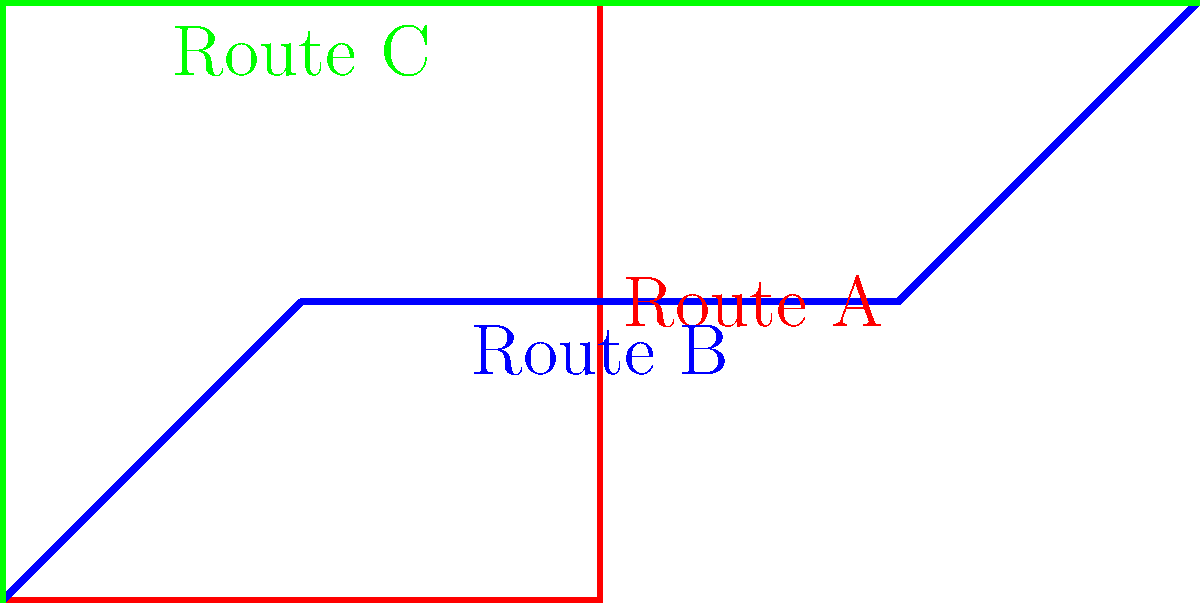Based on the TriMet bus route map shown, which route provides the most direct path from the start point to the end point? To determine the most direct route, we need to analyze each path:

1. Route A (red):
   - Moves east, then north, then east again
   - Has two 90-degree turns
   - Covers more distance than necessary

2. Route B (blue):
   - Moves diagonally northeast, then east
   - Has one gentle turn
   - Provides a more direct path than Route A

3. Route C (green):
   - Moves north, then east
   - Has one 90-degree turn
   - Covers the least distance among all routes

By comparing these routes, we can see that Route B (blue) provides the most direct path from the start to the end point. It has the least deviation from a straight line and requires only one gentle turn, making it the optimal choice for a direct route.
Answer: Route B 